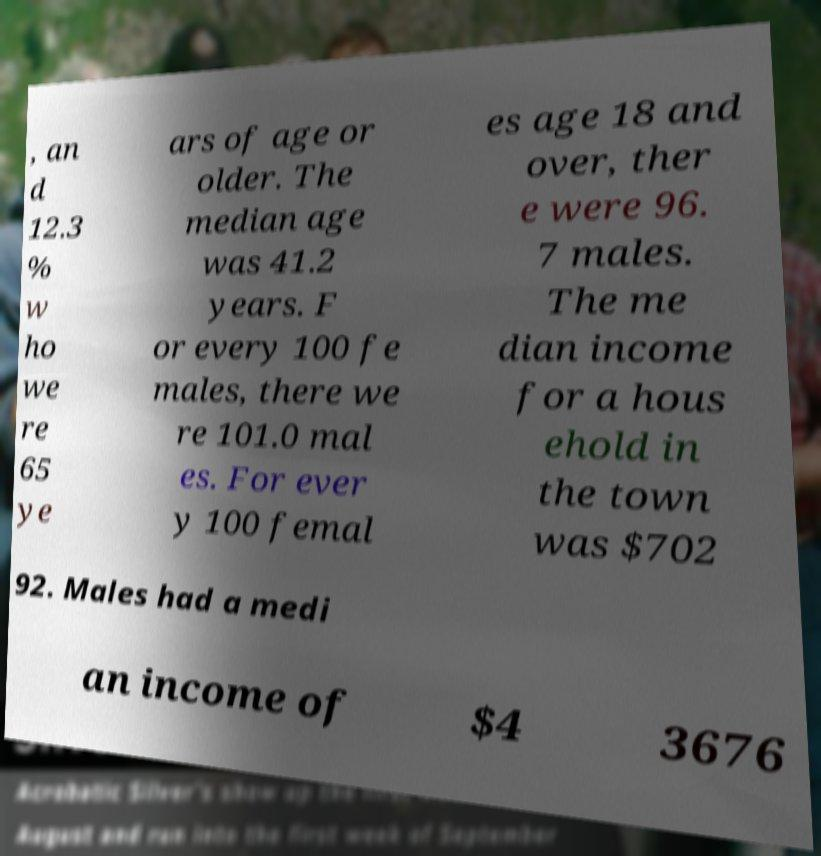Can you accurately transcribe the text from the provided image for me? , an d 12.3 % w ho we re 65 ye ars of age or older. The median age was 41.2 years. F or every 100 fe males, there we re 101.0 mal es. For ever y 100 femal es age 18 and over, ther e were 96. 7 males. The me dian income for a hous ehold in the town was $702 92. Males had a medi an income of $4 3676 